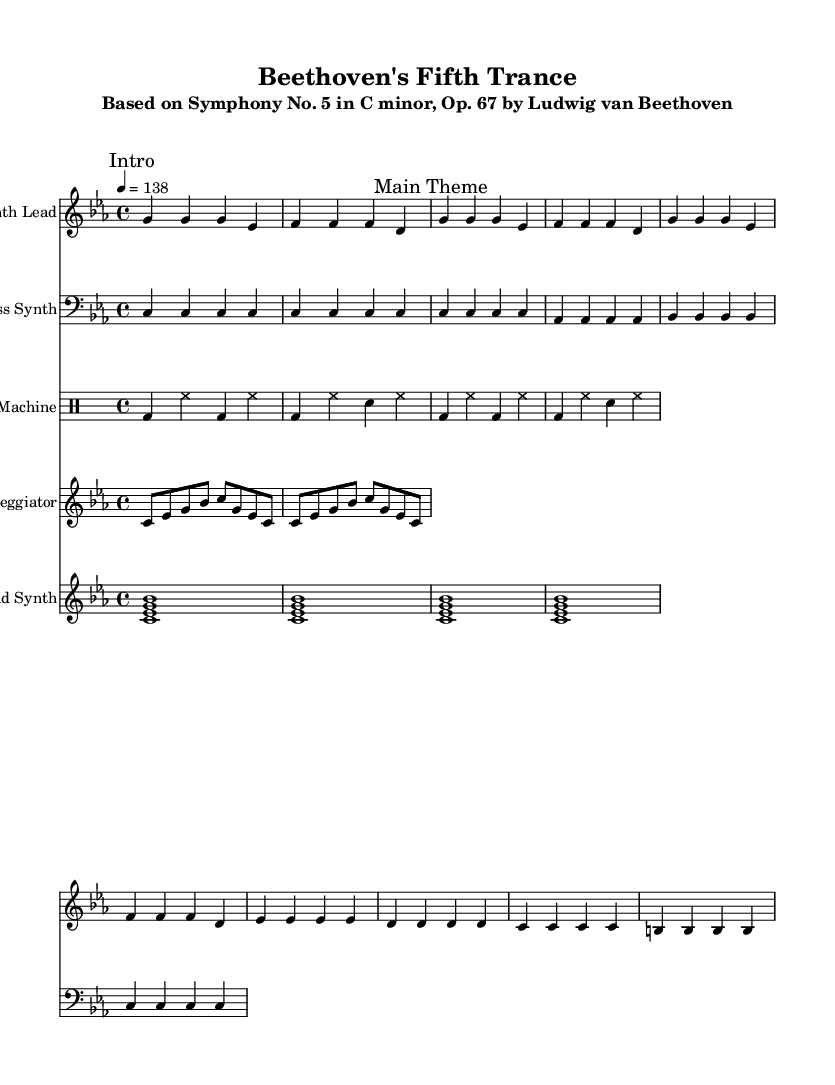What is the key signature of this music? The key signature is indicated by the presence of three flats in the key signature section at the beginning of the score, which corresponds to C minor.
Answer: C minor What is the time signature of this piece? The time signature is shown at the start of the score as 4/4, meaning there are four beats per measure and the quarter note gets one beat.
Answer: 4/4 What is the tempo marking for this composition? The tempo is marked at the beginning as "4 = 138," indicating a tempo of 138 beats per minute in quarter notes.
Answer: 138 How many measures are there in the main theme section? The main theme is represented by a repeated sequence that spans 8 measures in total as counted during the section marked as "Main Theme."
Answer: 8 measures What instruments are present in this arrangement? The piece includes a Synth Lead, Bass Synth, Drum Machine, Arpeggiator, and Pad Synth, all indicated at the beginning of their respective staves.
Answer: Synth Lead, Bass Synth, Drum Machine, Arpeggiator, Pad Synth What rhythmic elements are emphasized in the drum section? The drum section features a pattern of bass drum (bd) and hi-hat (hh) in alternating measures, emphasizing a steady beat with the snare (sn) appearing on certain beats for contrast.
Answer: Bass drum and hi-hat 